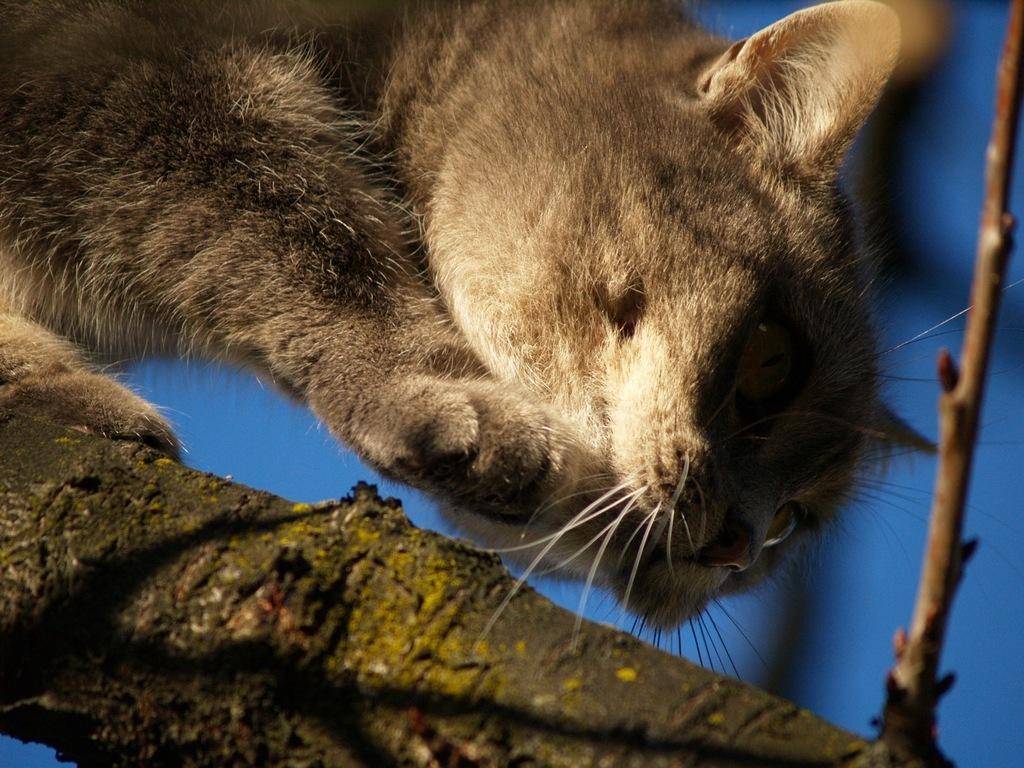In one or two sentences, can you explain what this image depicts? In this image I can see the cat in brown and cream color and I can see the blue color background. 